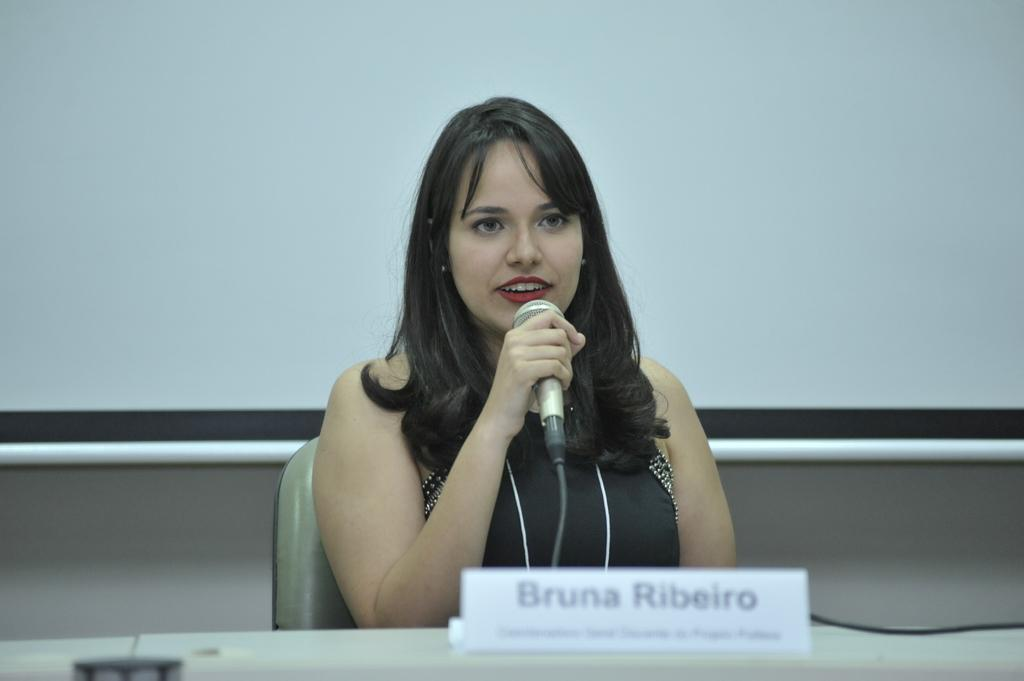What is the person in the image doing? The person is holding a microphone and sitting. What might the person be using the microphone for? The person might be using the microphone for speaking or presenting. What can be seen on the board in the image? There is text on the board in the image. What is in the background of the image? There is a projector screen and a wall in the background. What type of dirt can be seen on the person's knee in the image? There is no dirt or knee visible in the image; the person is sitting and holding a microphone. 